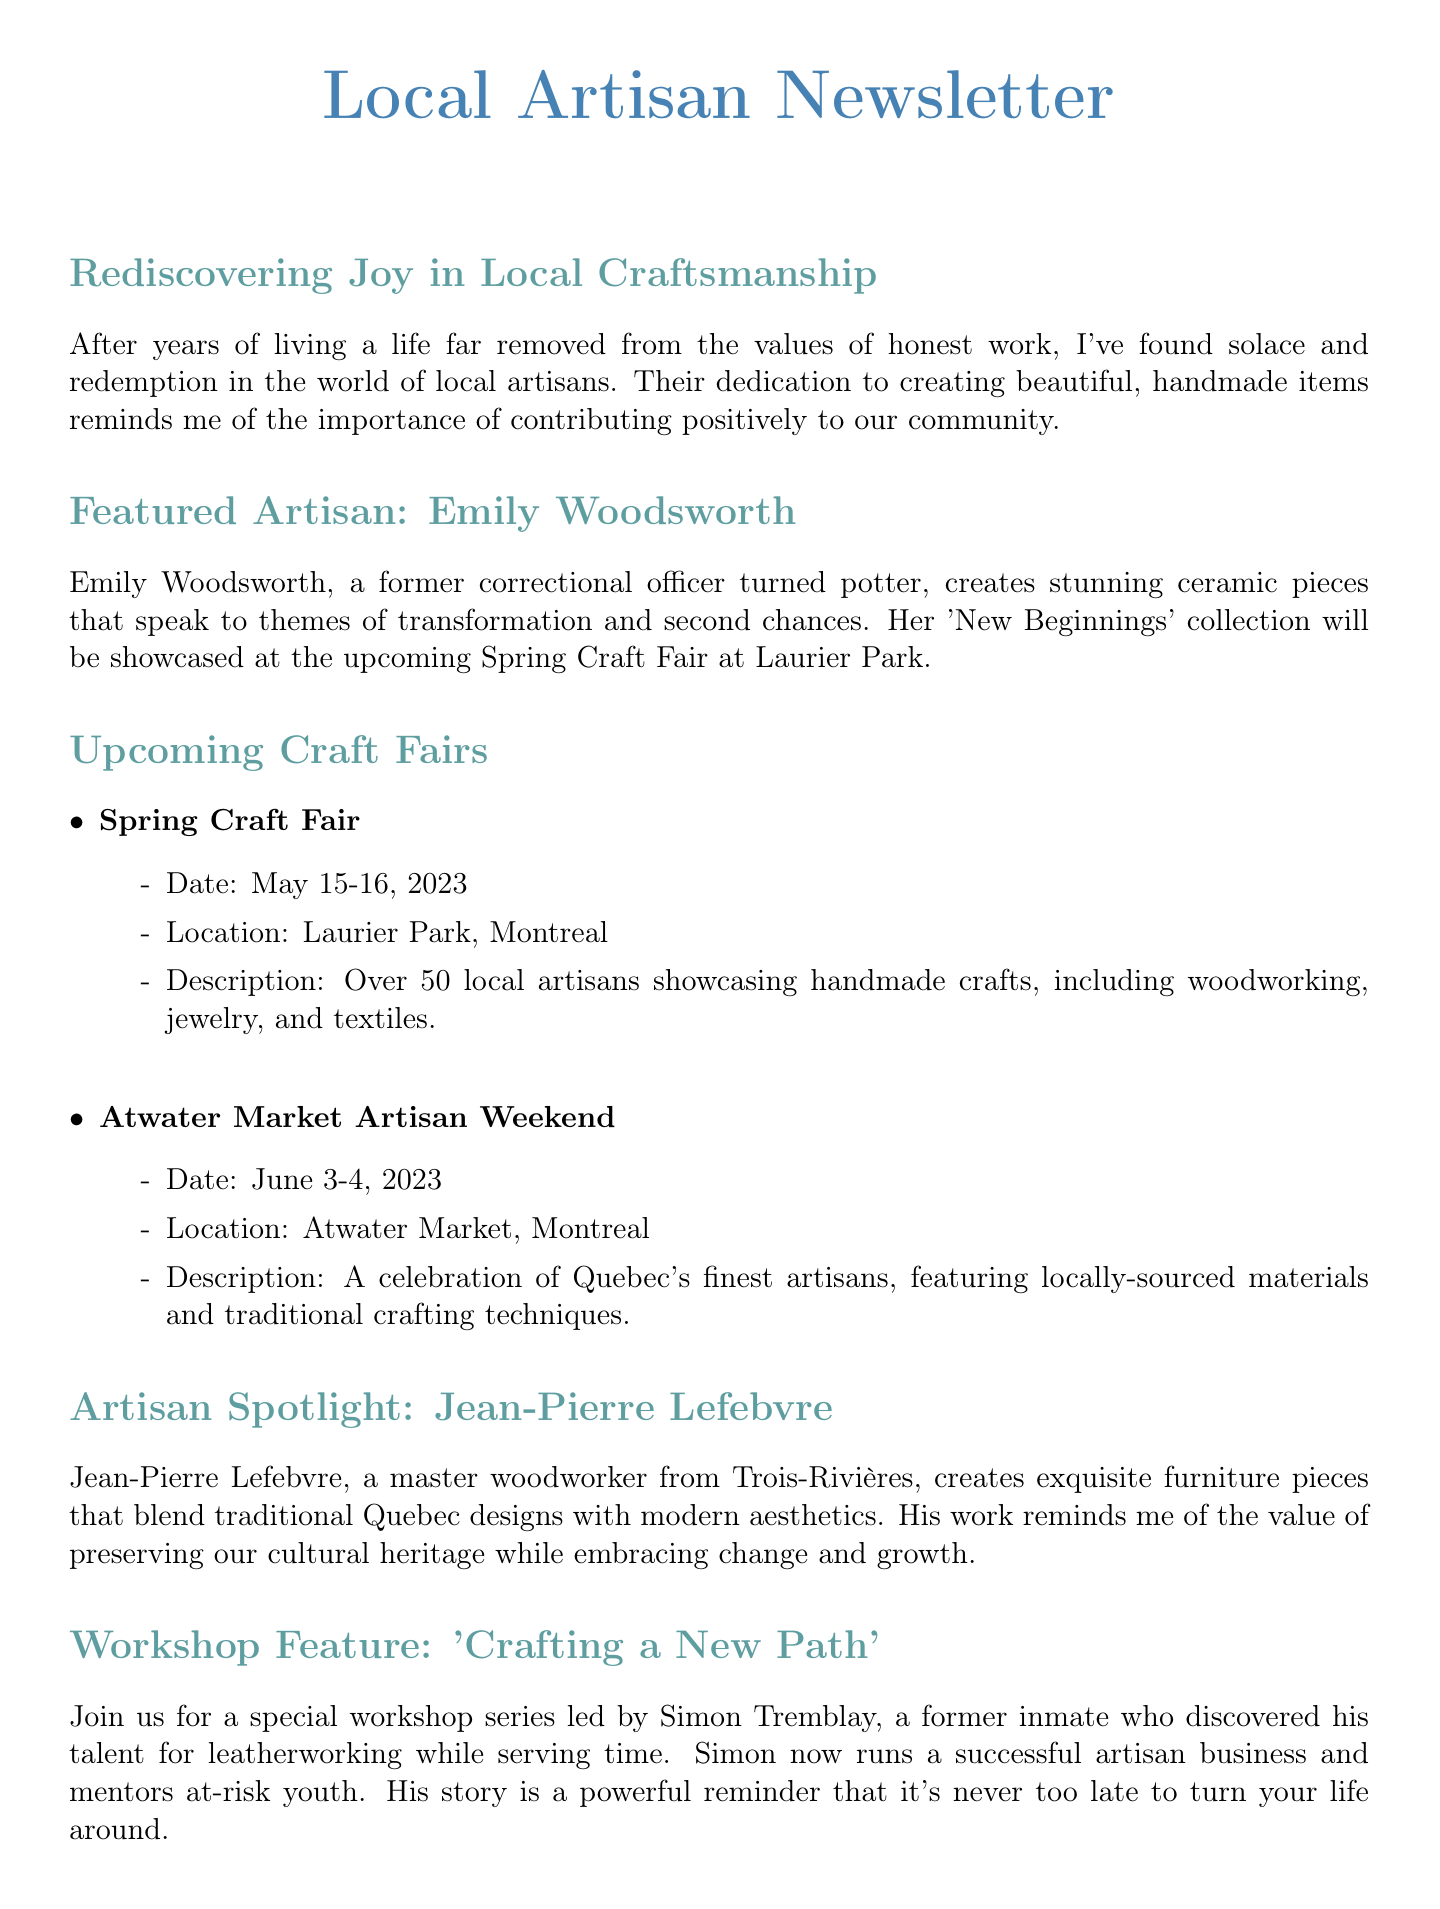What is the name of the featured artisan? The document specifies Emily Woodsworth as the featured artisan.
Answer: Emily Woodsworth When is the Spring Craft Fair taking place? The document states the date for the Spring Craft Fair as May 15-16, 2023.
Answer: May 15-16, 2023 What type of crafts does Jean-Pierre Lefebvre create? The content mentions Jean-Pierre Lefebvre creates exquisite furniture pieces.
Answer: Furniture What is the theme of Emily Woodsworth's collection? The document indicates that her collection speaks to themes of transformation and second chances.
Answer: Transformation and second chances Who leads the workshop series titled 'Crafting a New Path'? The document provides the name of the workshop leader as Simon Tremblay.
Answer: Simon Tremblay How many local artisans will showcase their work at the Spring Craft Fair? The document states that there will be over 50 local artisans at the Spring Craft Fair.
Answer: Over 50 Where is Marché Bonsecours located? The document specifies that Marché Bonsecours is located in the heart of Old Montreal.
Answer: Old Montreal What does the newsletter encourage readers to do regarding local artisans? The content suggests that readers should invest in their community by purchasing from local artisans.
Answer: Invest in the community What type of materials does the Atwater Market Artisan Weekend celebrate? The document notes that the event features locally-sourced materials.
Answer: Locally-sourced materials 